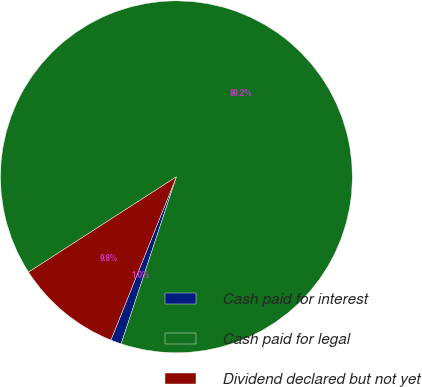Convert chart to OTSL. <chart><loc_0><loc_0><loc_500><loc_500><pie_chart><fcel>Cash paid for interest<fcel>Cash paid for legal<fcel>Dividend declared but not yet<nl><fcel>0.99%<fcel>89.19%<fcel>9.81%<nl></chart> 